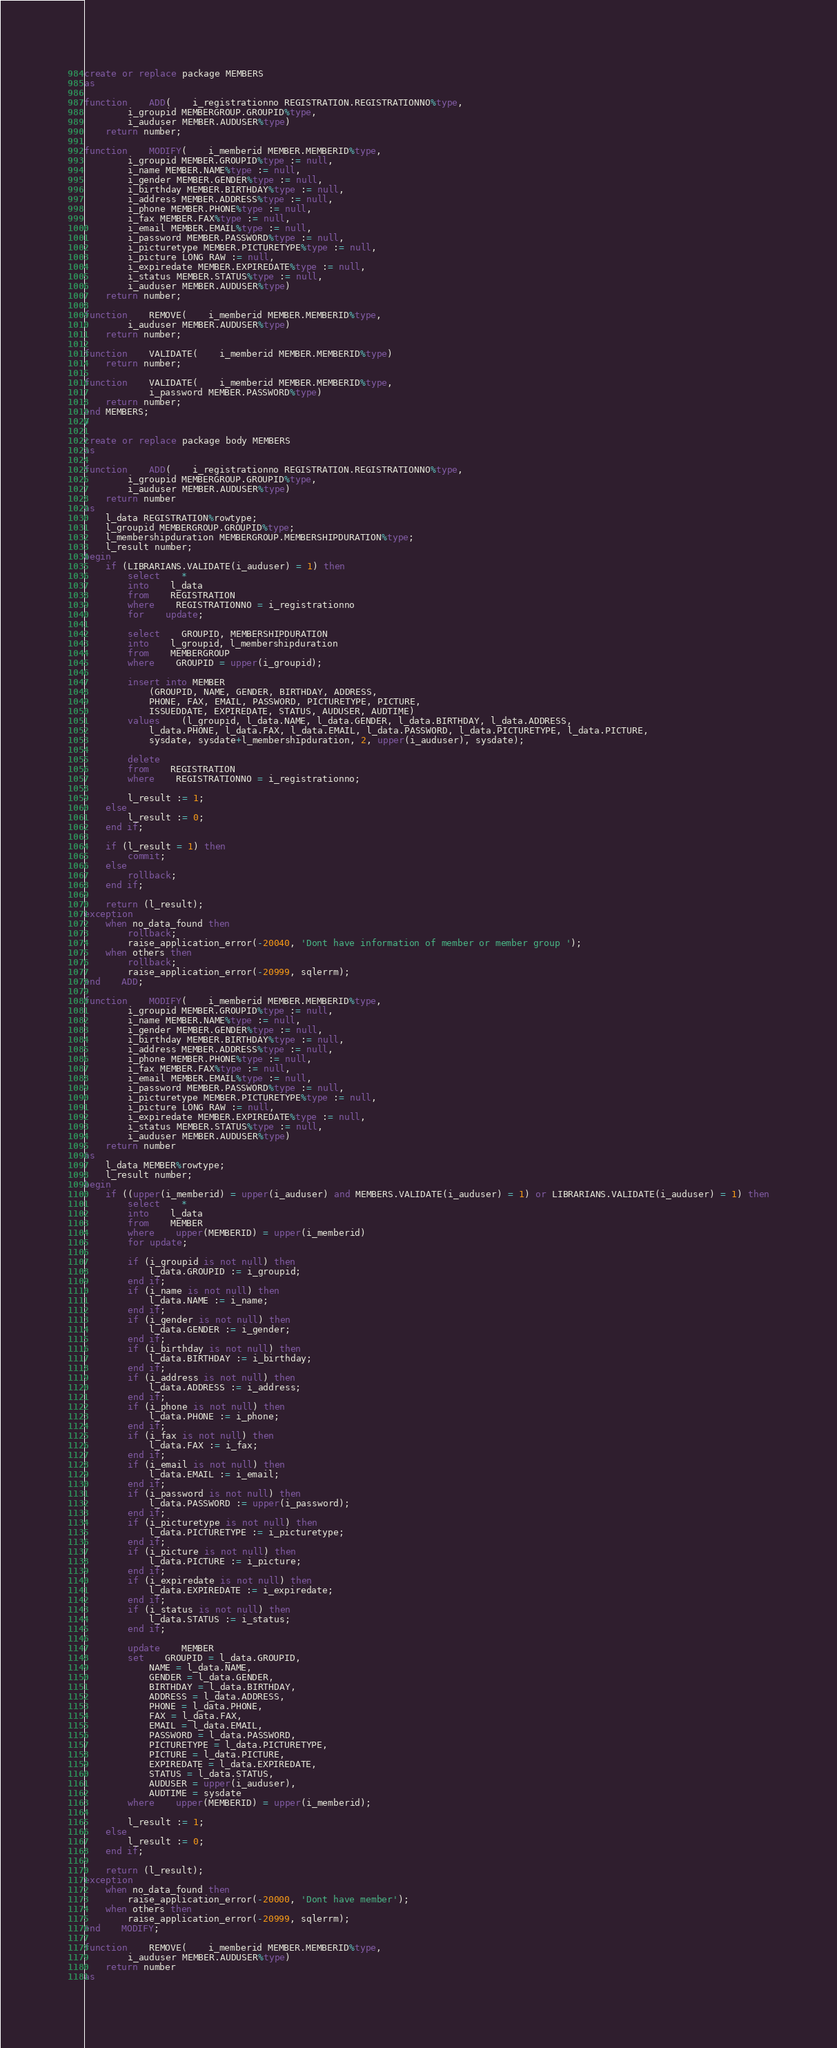Convert code to text. <code><loc_0><loc_0><loc_500><loc_500><_SQL_>create or replace package MEMBERS
as

function	ADD(	i_registrationno REGISTRATION.REGISTRATIONNO%type,
		i_groupid MEMBERGROUP.GROUPID%type,
		i_auduser MEMBER.AUDUSER%type)
	return number;

function	MODIFY(	i_memberid MEMBER.MEMBERID%type,
		i_groupid MEMBER.GROUPID%type := null,
		i_name MEMBER.NAME%type := null,
		i_gender MEMBER.GENDER%type := null,
		i_birthday MEMBER.BIRTHDAY%type := null,
		i_address MEMBER.ADDRESS%type := null,
		i_phone MEMBER.PHONE%type := null,
		i_fax MEMBER.FAX%type := null,
		i_email MEMBER.EMAIL%type := null,
		i_password MEMBER.PASSWORD%type := null,
		i_picturetype MEMBER.PICTURETYPE%type := null,
		i_picture LONG RAW := null,
		i_expiredate MEMBER.EXPIREDATE%type := null,
		i_status MEMBER.STATUS%type := null,
		i_auduser MEMBER.AUDUSER%type)
	return number;

function	REMOVE(	i_memberid MEMBER.MEMBERID%type,
		i_auduser MEMBER.AUDUSER%type)
	return number;

function	VALIDATE(	i_memberid MEMBER.MEMBERID%type)
	return number;

function	VALIDATE(	i_memberid MEMBER.MEMBERID%type,
			i_password MEMBER.PASSWORD%type)
	return number;
end MEMBERS;
/

create or replace package body MEMBERS
as

function	ADD(	i_registrationno REGISTRATION.REGISTRATIONNO%type,
		i_groupid MEMBERGROUP.GROUPID%type,
		i_auduser MEMBER.AUDUSER%type)
	return number
as
	l_data REGISTRATION%rowtype;
	l_groupid MEMBERGROUP.GROUPID%type;
	l_membershipduration MEMBERGROUP.MEMBERSHIPDURATION%type;
	l_result number;
begin
	if (LIBRARIANS.VALIDATE(i_auduser) = 1) then
		select	*
		into	l_data
		from	REGISTRATION
		where	REGISTRATIONNO = i_registrationno
		for	update;

		select	GROUPID, MEMBERSHIPDURATION
		into	l_groupid, l_membershipduration
		from	MEMBERGROUP
		where	GROUPID = upper(i_groupid);

		insert into MEMBER
			(GROUPID, NAME, GENDER, BIRTHDAY, ADDRESS, 
			PHONE, FAX, EMAIL, PASSWORD, PICTURETYPE, PICTURE, 
			ISSUEDDATE, EXPIREDATE, STATUS, AUDUSER, AUDTIME)
		values	(l_groupid, l_data.NAME, l_data.GENDER, l_data.BIRTHDAY, l_data.ADDRESS, 
			l_data.PHONE, l_data.FAX, l_data.EMAIL, l_data.PASSWORD, l_data.PICTURETYPE, l_data.PICTURE,
			sysdate, sysdate+l_membershipduration, 2, upper(i_auduser), sysdate);

		delete
		from	REGISTRATION
		where	REGISTRATIONNO = i_registrationno;

		l_result := 1;
	else	
		l_result := 0;
	end if;

	if (l_result = 1) then
		commit;
	else
		rollback;
	end if;
	
	return (l_result);
exception
	when no_data_found then
		rollback;
		raise_application_error(-20040, 'Dont have information of member or member group ');
	when others then
		rollback;
		raise_application_error(-20999, sqlerrm);
end	ADD;

function	MODIFY(	i_memberid MEMBER.MEMBERID%type,
		i_groupid MEMBER.GROUPID%type := null,
		i_name MEMBER.NAME%type := null,
		i_gender MEMBER.GENDER%type := null,
		i_birthday MEMBER.BIRTHDAY%type := null,
		i_address MEMBER.ADDRESS%type := null,
		i_phone MEMBER.PHONE%type := null,
		i_fax MEMBER.FAX%type := null,
		i_email MEMBER.EMAIL%type := null,
		i_password MEMBER.PASSWORD%type := null,
		i_picturetype MEMBER.PICTURETYPE%type := null,
		i_picture LONG RAW := null,
		i_expiredate MEMBER.EXPIREDATE%type := null,
		i_status MEMBER.STATUS%type := null,
		i_auduser MEMBER.AUDUSER%type)
	return number
as
	l_data MEMBER%rowtype;
	l_result number;
begin
	if ((upper(i_memberid) = upper(i_auduser) and MEMBERS.VALIDATE(i_auduser) = 1) or LIBRARIANS.VALIDATE(i_auduser) = 1) then
		select	*
		into	l_data
		from	MEMBER
		where	upper(MEMBERID) = upper(i_memberid)
		for update;

		if (i_groupid is not null) then
			l_data.GROUPID := i_groupid;
		end if;
		if (i_name is not null) then
			l_data.NAME := i_name;
		end if;
		if (i_gender is not null) then
			l_data.GENDER := i_gender;
		end if;
		if (i_birthday is not null) then
			l_data.BIRTHDAY := i_birthday;
		end if;
		if (i_address is not null) then
			l_data.ADDRESS := i_address;
		end if;
		if (i_phone is not null) then
			l_data.PHONE := i_phone;
		end if;
		if (i_fax is not null) then
			l_data.FAX := i_fax;
		end if;
		if (i_email is not null) then
			l_data.EMAIL := i_email;
		end if;
		if (i_password is not null) then
			l_data.PASSWORD := upper(i_password);
		end if;
		if (i_picturetype is not null) then
			l_data.PICTURETYPE := i_picturetype;
		end if;
		if (i_picture is not null) then
			l_data.PICTURE := i_picture;
		end if;
		if (i_expiredate is not null) then
			l_data.EXPIREDATE := i_expiredate;
		end if;
		if (i_status is not null) then
			l_data.STATUS := i_status;
		end if;

		update	MEMBER
		set	GROUPID = l_data.GROUPID,
			NAME = l_data.NAME,
			GENDER = l_data.GENDER,
			BIRTHDAY = l_data.BIRTHDAY,
			ADDRESS = l_data.ADDRESS,
			PHONE = l_data.PHONE,
			FAX = l_data.FAX,
			EMAIL = l_data.EMAIL,
			PASSWORD = l_data.PASSWORD,
			PICTURETYPE = l_data.PICTURETYPE,
			PICTURE = l_data.PICTURE,
			EXPIREDATE = l_data.EXPIREDATE,
			STATUS = l_data.STATUS,
			AUDUSER = upper(i_auduser),
			AUDTIME = sysdate
		where	upper(MEMBERID) = upper(i_memberid);
	
		l_result := 1;
	else
		l_result := 0;
	end if;
	
	return (l_result);
exception
	when no_data_found then
		raise_application_error(-20000, 'Dont have member');
	when others then
		raise_application_error(-20999, sqlerrm);
end	MODIFY;

function	REMOVE(	i_memberid MEMBER.MEMBERID%type,
		i_auduser MEMBER.AUDUSER%type)
	return number
as</code> 